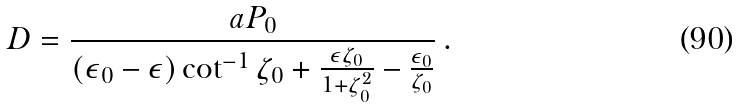<formula> <loc_0><loc_0><loc_500><loc_500>D = \frac { a P _ { 0 } } { ( \epsilon _ { 0 } - \epsilon ) \cot ^ { - 1 } \zeta _ { 0 } + \frac { \epsilon \zeta _ { 0 } } { 1 + \zeta _ { 0 } ^ { 2 } } - \frac { \epsilon _ { 0 } } { \zeta _ { 0 } } } \, .</formula> 